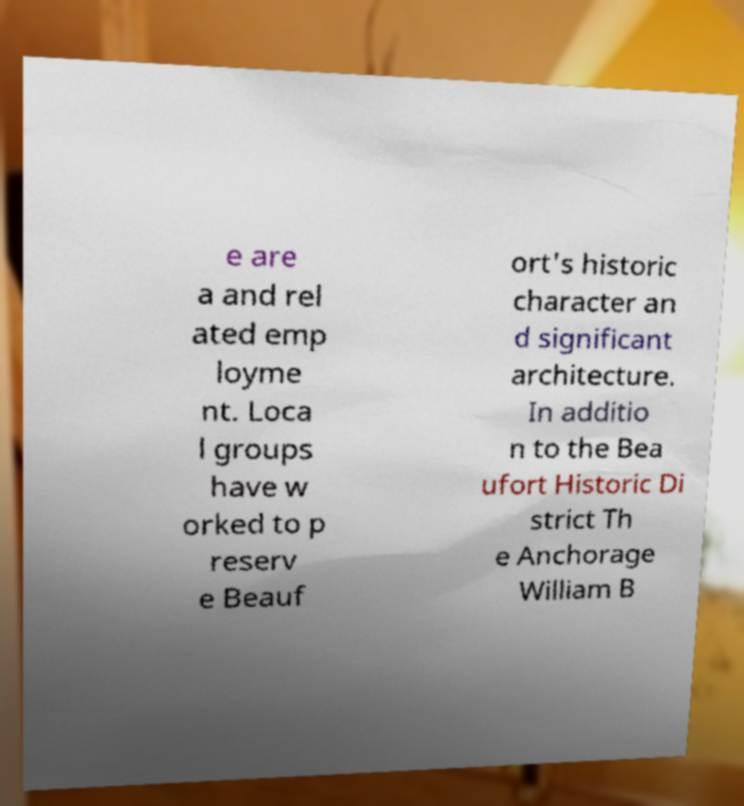Please identify and transcribe the text found in this image. e are a and rel ated emp loyme nt. Loca l groups have w orked to p reserv e Beauf ort's historic character an d significant architecture. In additio n to the Bea ufort Historic Di strict Th e Anchorage William B 